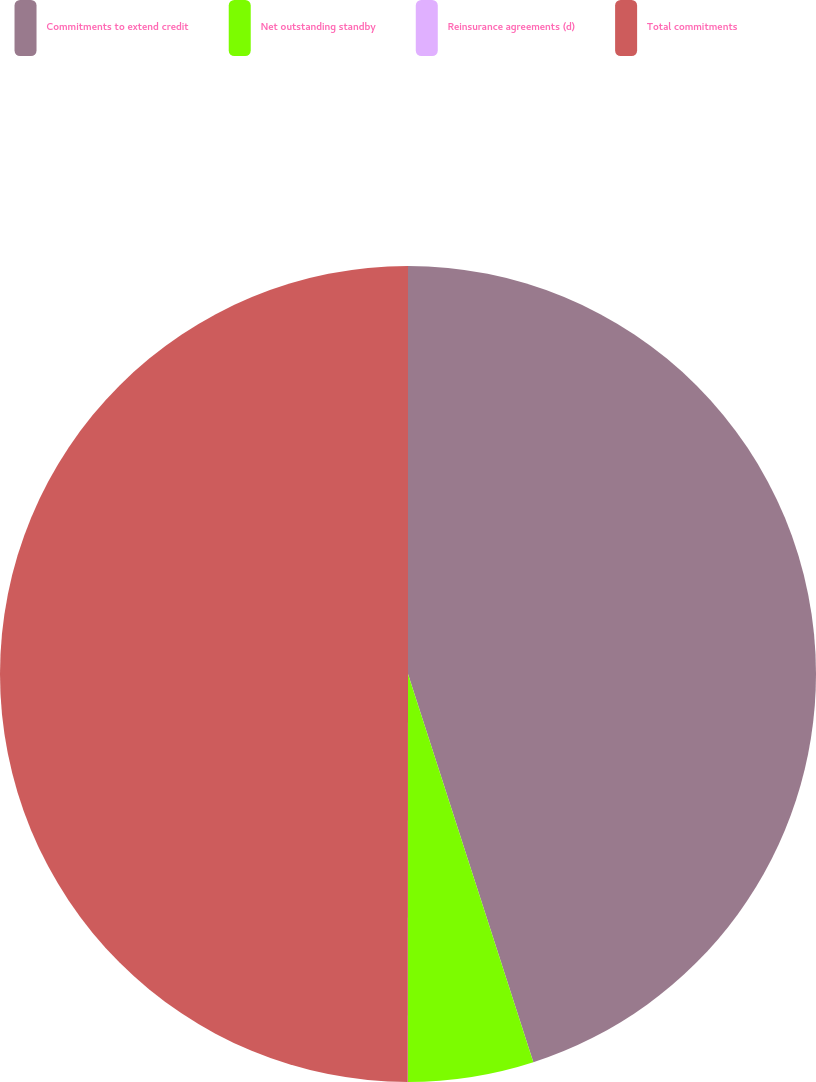Convert chart to OTSL. <chart><loc_0><loc_0><loc_500><loc_500><pie_chart><fcel>Commitments to extend credit<fcel>Net outstanding standby<fcel>Reinsurance agreements (d)<fcel>Total commitments<nl><fcel>45.03%<fcel>4.97%<fcel>0.01%<fcel>49.99%<nl></chart> 